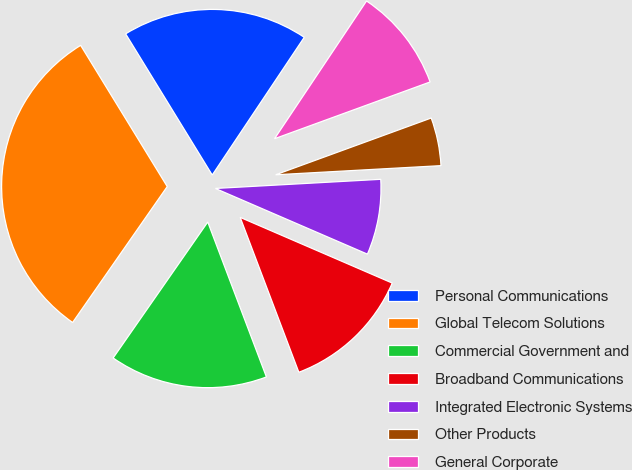Convert chart to OTSL. <chart><loc_0><loc_0><loc_500><loc_500><pie_chart><fcel>Personal Communications<fcel>Global Telecom Solutions<fcel>Commercial Government and<fcel>Broadband Communications<fcel>Integrated Electronic Systems<fcel>Other Products<fcel>General Corporate<nl><fcel>18.13%<fcel>31.57%<fcel>15.44%<fcel>12.75%<fcel>7.37%<fcel>4.69%<fcel>10.06%<nl></chart> 